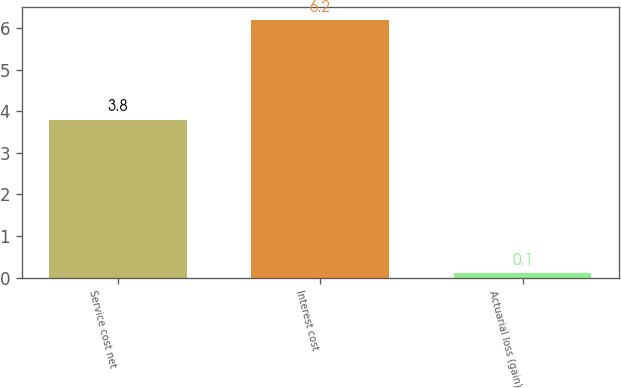<chart> <loc_0><loc_0><loc_500><loc_500><bar_chart><fcel>Service cost net<fcel>Interest cost<fcel>Actuarial loss (gain)<nl><fcel>3.8<fcel>6.2<fcel>0.1<nl></chart> 